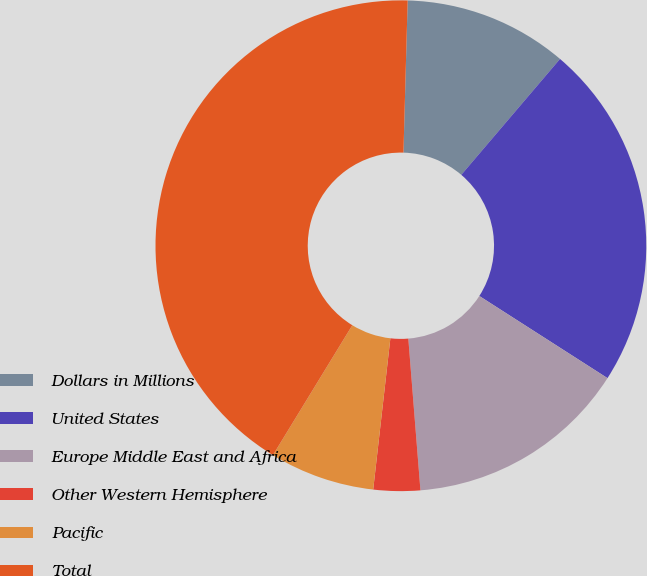<chart> <loc_0><loc_0><loc_500><loc_500><pie_chart><fcel>Dollars in Millions<fcel>United States<fcel>Europe Middle East and Africa<fcel>Other Western Hemisphere<fcel>Pacific<fcel>Total<nl><fcel>10.79%<fcel>22.84%<fcel>14.66%<fcel>3.07%<fcel>6.93%<fcel>41.71%<nl></chart> 